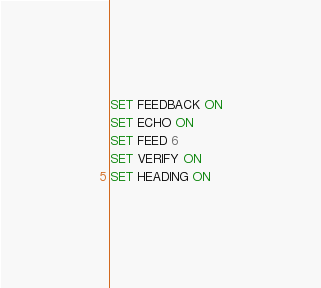<code> <loc_0><loc_0><loc_500><loc_500><_SQL_>SET FEEDBACK ON
SET ECHO ON
SET FEED 6
SET VERIFY ON
SET HEADING ON
</code> 